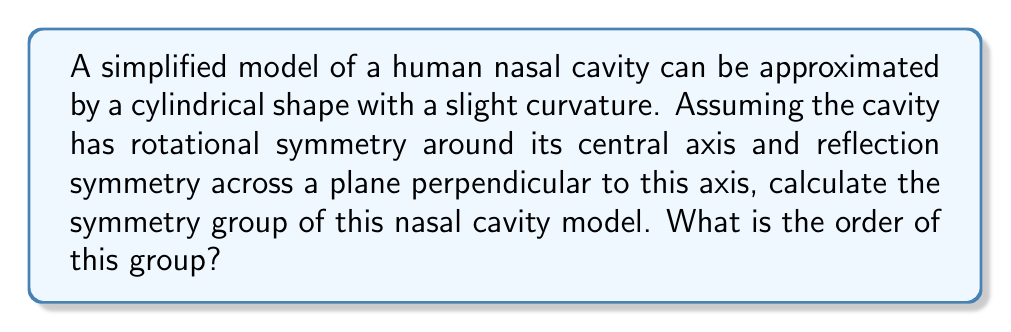What is the answer to this math problem? To determine the symmetry group of the nasal cavity model, we'll follow these steps:

1) Identify the symmetries:
   a) Rotational symmetry around the central axis
   b) Reflection symmetry across a plane perpendicular to the axis

2) The rotational symmetry is continuous, meaning we can rotate the model by any angle around its axis. This is represented by the group $SO(2)$.

3) The reflection symmetry adds a mirror plane, which doubles the number of symmetries. This is represented by $\mathbb{Z}_2$.

4) The combination of these symmetries forms a direct product of $SO(2)$ and $\mathbb{Z}_2$.

5) Therefore, the symmetry group is $SO(2) \times \mathbb{Z}_2$.

6) This group is also known as $O(2)$, the orthogonal group in 2 dimensions.

7) To determine the order of the group:
   - $SO(2)$ has infinitely many elements (continuous rotations)
   - $\mathbb{Z}_2$ has 2 elements (identity and reflection)
   - The direct product of an infinite group with a finite group results in an infinite group

Therefore, the order of the symmetry group $O(2)$ is infinite.
Answer: $O(2)$, infinite order 